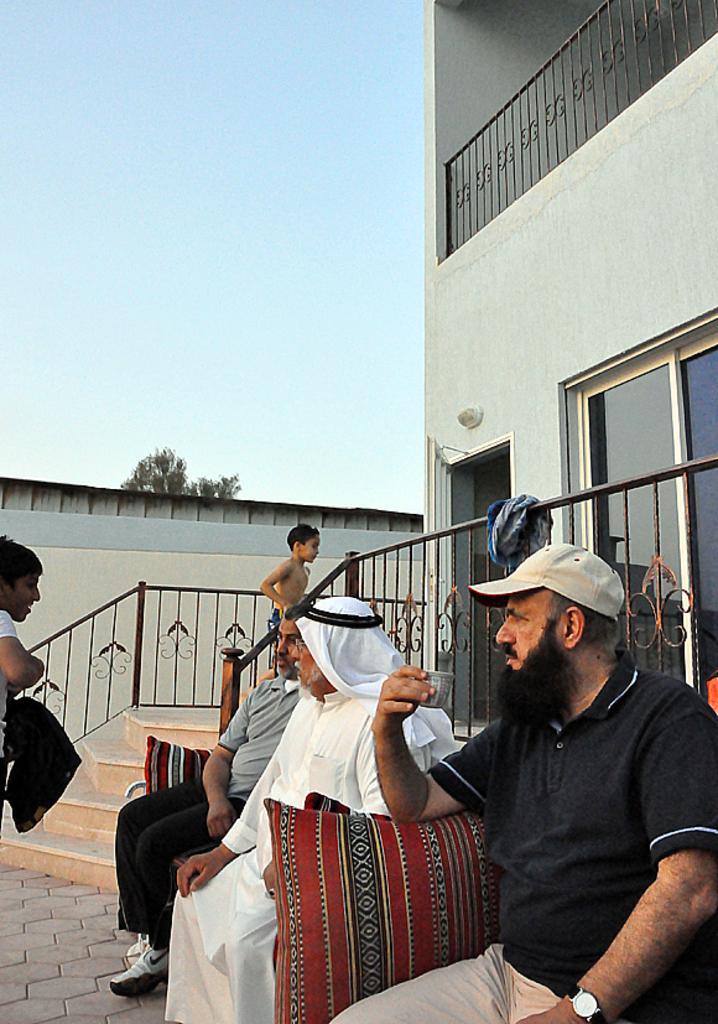Describe this image in one or two sentences. At the bottom of the image few people are sitting and standing. Behind them we can see fencing and steps. Behind the fencing we can see some buildings and trees. In the top left corner of the image we can see the sky. 